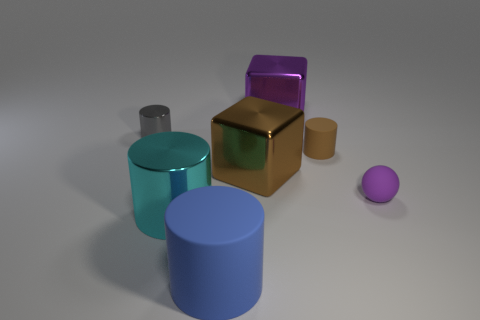Subtract all gray metal cylinders. How many cylinders are left? 3 Subtract all cyan cylinders. How many cylinders are left? 3 Add 2 big red metallic balls. How many objects exist? 9 Subtract all spheres. How many objects are left? 6 Subtract all small brown cubes. Subtract all rubber cylinders. How many objects are left? 5 Add 3 metal cylinders. How many metal cylinders are left? 5 Add 7 large brown matte cylinders. How many large brown matte cylinders exist? 7 Subtract 1 cyan cylinders. How many objects are left? 6 